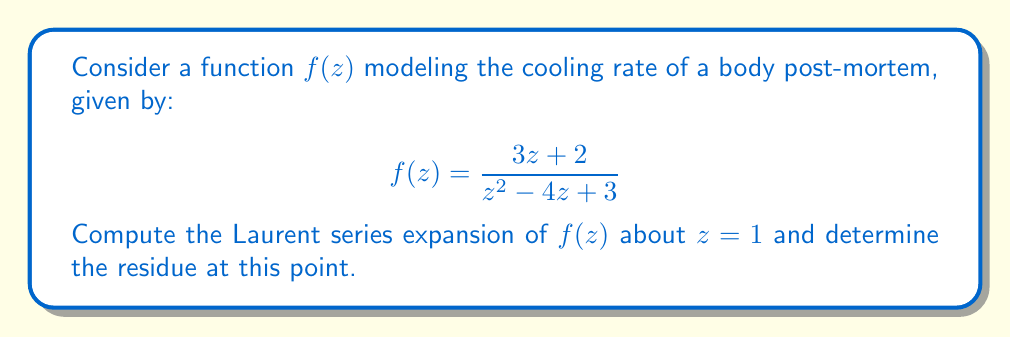Can you solve this math problem? To find the Laurent series expansion of $f(z)$ about $z = 1$, we follow these steps:

1) First, we rewrite the function in terms of $(z-1)$:
   $$f(z) = \frac{3z + 2}{z^2 - 4z + 3} = \frac{3(z-1) + 5}{(z-1)^2 - 2(z-1) + 0}$$

2) We can simplify the denominator:
   $$f(z) = \frac{3(z-1) + 5}{(z-1)(z-3)}$$

3) Now, we use partial fraction decomposition:
   $$f(z) = \frac{A}{z-1} + \frac{B}{z-3}$$

   where $A$ and $B$ are constants to be determined.

4) Multiplying both sides by $(z-1)(z-3)$:
   $3(z-1) + 5 = A(z-3) + B(z-1)$

5) Substituting $z=1$ and $z=3$, we get:
   $5 = -2A$ and $11 = 2B$
   Thus, $A = -\frac{5}{2}$ and $B = \frac{11}{2}$

6) Our function can now be written as:
   $$f(z) = -\frac{5/2}{z-1} + \frac{11/2}{z-3}$$

7) The Laurent series expansion about $z=1$ for the second term is straightforward:
   $$\frac{11/2}{z-3} = \frac{11/2}{(z-1)-2} = \frac{11/4}{1-\frac{z-1}{2}} = \frac{11}{4}\sum_{n=0}^{\infty}\frac{(z-1)^n}{2^n}$$

8) Combining with the first term, we get the Laurent series:
   $$f(z) = -\frac{5/2}{z-1} + \frac{11}{4}\sum_{n=0}^{\infty}\frac{(z-1)^n}{2^n}$$

9) The residue at $z=1$ is the coefficient of $\frac{1}{z-1}$ in the Laurent series, which is $-\frac{5}{2}$.
Answer: The Laurent series expansion of $f(z)$ about $z=1$ is:

$$f(z) = -\frac{5/2}{z-1} + \frac{11}{4}\sum_{n=0}^{\infty}\frac{(z-1)^n}{2^n}$$

The residue at $z=1$ is $-\frac{5}{2}$. 